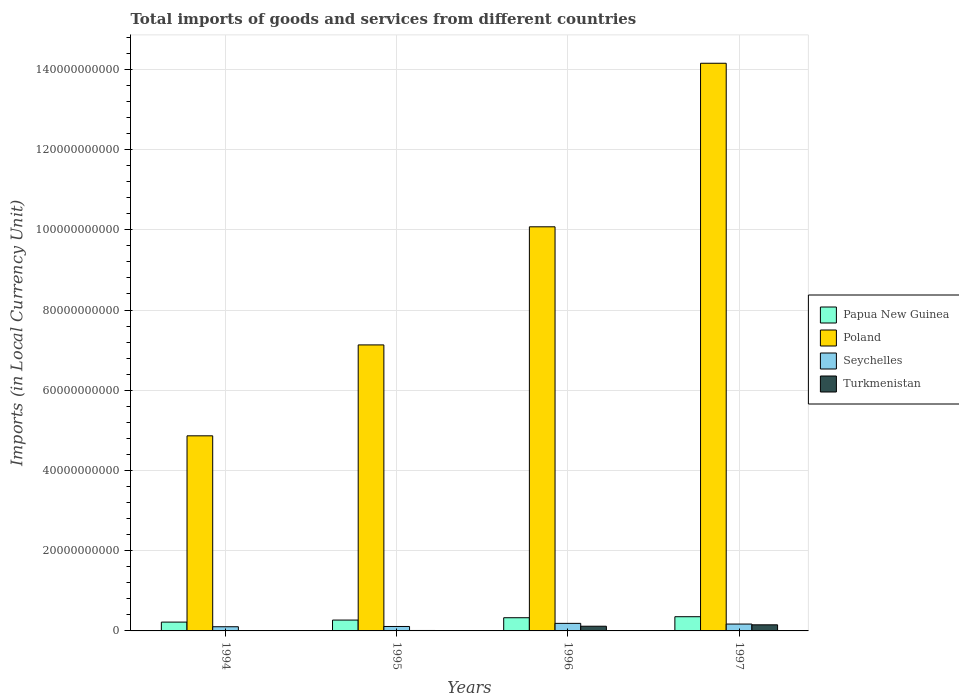How many different coloured bars are there?
Ensure brevity in your answer.  4. How many bars are there on the 2nd tick from the left?
Provide a succinct answer. 4. How many bars are there on the 3rd tick from the right?
Provide a short and direct response. 4. What is the Amount of goods and services imports in Poland in 1997?
Keep it short and to the point. 1.42e+11. Across all years, what is the maximum Amount of goods and services imports in Papua New Guinea?
Your response must be concise. 3.54e+09. Across all years, what is the minimum Amount of goods and services imports in Poland?
Your answer should be very brief. 4.86e+1. In which year was the Amount of goods and services imports in Poland minimum?
Your answer should be compact. 1994. What is the total Amount of goods and services imports in Papua New Guinea in the graph?
Your answer should be compact. 1.17e+1. What is the difference between the Amount of goods and services imports in Papua New Guinea in 1996 and that in 1997?
Provide a short and direct response. -2.55e+08. What is the difference between the Amount of goods and services imports in Seychelles in 1997 and the Amount of goods and services imports in Turkmenistan in 1994?
Make the answer very short. 1.70e+09. What is the average Amount of goods and services imports in Turkmenistan per year?
Provide a short and direct response. 7.04e+08. In the year 1994, what is the difference between the Amount of goods and services imports in Poland and Amount of goods and services imports in Turkmenistan?
Your response must be concise. 4.86e+1. In how many years, is the Amount of goods and services imports in Turkmenistan greater than 8000000000 LCU?
Your answer should be compact. 0. What is the ratio of the Amount of goods and services imports in Seychelles in 1995 to that in 1996?
Provide a succinct answer. 0.59. Is the difference between the Amount of goods and services imports in Poland in 1995 and 1997 greater than the difference between the Amount of goods and services imports in Turkmenistan in 1995 and 1997?
Your response must be concise. No. What is the difference between the highest and the second highest Amount of goods and services imports in Poland?
Make the answer very short. 4.08e+1. What is the difference between the highest and the lowest Amount of goods and services imports in Seychelles?
Your answer should be very brief. 8.40e+08. Is the sum of the Amount of goods and services imports in Poland in 1994 and 1996 greater than the maximum Amount of goods and services imports in Papua New Guinea across all years?
Keep it short and to the point. Yes. Is it the case that in every year, the sum of the Amount of goods and services imports in Seychelles and Amount of goods and services imports in Papua New Guinea is greater than the sum of Amount of goods and services imports in Turkmenistan and Amount of goods and services imports in Poland?
Provide a short and direct response. Yes. What does the 3rd bar from the left in 1995 represents?
Your response must be concise. Seychelles. What does the 3rd bar from the right in 1995 represents?
Offer a terse response. Poland. How many bars are there?
Ensure brevity in your answer.  16. Are all the bars in the graph horizontal?
Provide a succinct answer. No. How many years are there in the graph?
Your response must be concise. 4. Does the graph contain any zero values?
Your answer should be very brief. No. Does the graph contain grids?
Make the answer very short. Yes. How many legend labels are there?
Offer a terse response. 4. How are the legend labels stacked?
Offer a terse response. Vertical. What is the title of the graph?
Offer a very short reply. Total imports of goods and services from different countries. Does "Costa Rica" appear as one of the legend labels in the graph?
Offer a very short reply. No. What is the label or title of the Y-axis?
Offer a very short reply. Imports (in Local Currency Unit). What is the Imports (in Local Currency Unit) in Papua New Guinea in 1994?
Offer a terse response. 2.20e+09. What is the Imports (in Local Currency Unit) in Poland in 1994?
Your response must be concise. 4.86e+1. What is the Imports (in Local Currency Unit) of Seychelles in 1994?
Keep it short and to the point. 1.04e+09. What is the Imports (in Local Currency Unit) in Turkmenistan in 1994?
Your answer should be very brief. 1.49e+07. What is the Imports (in Local Currency Unit) of Papua New Guinea in 1995?
Offer a very short reply. 2.71e+09. What is the Imports (in Local Currency Unit) in Poland in 1995?
Ensure brevity in your answer.  7.13e+1. What is the Imports (in Local Currency Unit) of Seychelles in 1995?
Offer a very short reply. 1.11e+09. What is the Imports (in Local Currency Unit) of Turkmenistan in 1995?
Make the answer very short. 1.10e+08. What is the Imports (in Local Currency Unit) in Papua New Guinea in 1996?
Provide a succinct answer. 3.29e+09. What is the Imports (in Local Currency Unit) of Poland in 1996?
Your response must be concise. 1.01e+11. What is the Imports (in Local Currency Unit) of Seychelles in 1996?
Make the answer very short. 1.88e+09. What is the Imports (in Local Currency Unit) in Turkmenistan in 1996?
Your response must be concise. 1.17e+09. What is the Imports (in Local Currency Unit) in Papua New Guinea in 1997?
Your answer should be compact. 3.54e+09. What is the Imports (in Local Currency Unit) of Poland in 1997?
Your response must be concise. 1.42e+11. What is the Imports (in Local Currency Unit) of Seychelles in 1997?
Provide a short and direct response. 1.71e+09. What is the Imports (in Local Currency Unit) of Turkmenistan in 1997?
Give a very brief answer. 1.52e+09. Across all years, what is the maximum Imports (in Local Currency Unit) of Papua New Guinea?
Make the answer very short. 3.54e+09. Across all years, what is the maximum Imports (in Local Currency Unit) in Poland?
Your answer should be very brief. 1.42e+11. Across all years, what is the maximum Imports (in Local Currency Unit) in Seychelles?
Make the answer very short. 1.88e+09. Across all years, what is the maximum Imports (in Local Currency Unit) in Turkmenistan?
Your response must be concise. 1.52e+09. Across all years, what is the minimum Imports (in Local Currency Unit) of Papua New Guinea?
Your response must be concise. 2.20e+09. Across all years, what is the minimum Imports (in Local Currency Unit) in Poland?
Your answer should be very brief. 4.86e+1. Across all years, what is the minimum Imports (in Local Currency Unit) of Seychelles?
Keep it short and to the point. 1.04e+09. Across all years, what is the minimum Imports (in Local Currency Unit) in Turkmenistan?
Make the answer very short. 1.49e+07. What is the total Imports (in Local Currency Unit) in Papua New Guinea in the graph?
Your answer should be very brief. 1.17e+1. What is the total Imports (in Local Currency Unit) in Poland in the graph?
Your answer should be very brief. 3.62e+11. What is the total Imports (in Local Currency Unit) of Seychelles in the graph?
Ensure brevity in your answer.  5.74e+09. What is the total Imports (in Local Currency Unit) of Turkmenistan in the graph?
Offer a terse response. 2.82e+09. What is the difference between the Imports (in Local Currency Unit) of Papua New Guinea in 1994 and that in 1995?
Give a very brief answer. -5.08e+08. What is the difference between the Imports (in Local Currency Unit) in Poland in 1994 and that in 1995?
Make the answer very short. -2.27e+1. What is the difference between the Imports (in Local Currency Unit) of Seychelles in 1994 and that in 1995?
Your answer should be very brief. -6.68e+07. What is the difference between the Imports (in Local Currency Unit) of Turkmenistan in 1994 and that in 1995?
Keep it short and to the point. -9.49e+07. What is the difference between the Imports (in Local Currency Unit) in Papua New Guinea in 1994 and that in 1996?
Make the answer very short. -1.09e+09. What is the difference between the Imports (in Local Currency Unit) in Poland in 1994 and that in 1996?
Provide a succinct answer. -5.21e+1. What is the difference between the Imports (in Local Currency Unit) of Seychelles in 1994 and that in 1996?
Ensure brevity in your answer.  -8.40e+08. What is the difference between the Imports (in Local Currency Unit) of Turkmenistan in 1994 and that in 1996?
Ensure brevity in your answer.  -1.15e+09. What is the difference between the Imports (in Local Currency Unit) of Papua New Guinea in 1994 and that in 1997?
Give a very brief answer. -1.34e+09. What is the difference between the Imports (in Local Currency Unit) of Poland in 1994 and that in 1997?
Your answer should be very brief. -9.29e+1. What is the difference between the Imports (in Local Currency Unit) in Seychelles in 1994 and that in 1997?
Make the answer very short. -6.69e+08. What is the difference between the Imports (in Local Currency Unit) in Turkmenistan in 1994 and that in 1997?
Keep it short and to the point. -1.51e+09. What is the difference between the Imports (in Local Currency Unit) in Papua New Guinea in 1995 and that in 1996?
Make the answer very short. -5.81e+08. What is the difference between the Imports (in Local Currency Unit) in Poland in 1995 and that in 1996?
Your answer should be very brief. -2.94e+1. What is the difference between the Imports (in Local Currency Unit) of Seychelles in 1995 and that in 1996?
Your answer should be very brief. -7.73e+08. What is the difference between the Imports (in Local Currency Unit) of Turkmenistan in 1995 and that in 1996?
Provide a short and direct response. -1.06e+09. What is the difference between the Imports (in Local Currency Unit) in Papua New Guinea in 1995 and that in 1997?
Offer a very short reply. -8.36e+08. What is the difference between the Imports (in Local Currency Unit) of Poland in 1995 and that in 1997?
Your answer should be very brief. -7.02e+1. What is the difference between the Imports (in Local Currency Unit) in Seychelles in 1995 and that in 1997?
Give a very brief answer. -6.02e+08. What is the difference between the Imports (in Local Currency Unit) in Turkmenistan in 1995 and that in 1997?
Provide a succinct answer. -1.41e+09. What is the difference between the Imports (in Local Currency Unit) in Papua New Guinea in 1996 and that in 1997?
Give a very brief answer. -2.55e+08. What is the difference between the Imports (in Local Currency Unit) in Poland in 1996 and that in 1997?
Provide a succinct answer. -4.08e+1. What is the difference between the Imports (in Local Currency Unit) in Seychelles in 1996 and that in 1997?
Offer a very short reply. 1.71e+08. What is the difference between the Imports (in Local Currency Unit) in Turkmenistan in 1996 and that in 1997?
Make the answer very short. -3.54e+08. What is the difference between the Imports (in Local Currency Unit) of Papua New Guinea in 1994 and the Imports (in Local Currency Unit) of Poland in 1995?
Keep it short and to the point. -6.91e+1. What is the difference between the Imports (in Local Currency Unit) in Papua New Guinea in 1994 and the Imports (in Local Currency Unit) in Seychelles in 1995?
Provide a short and direct response. 1.09e+09. What is the difference between the Imports (in Local Currency Unit) in Papua New Guinea in 1994 and the Imports (in Local Currency Unit) in Turkmenistan in 1995?
Provide a short and direct response. 2.09e+09. What is the difference between the Imports (in Local Currency Unit) in Poland in 1994 and the Imports (in Local Currency Unit) in Seychelles in 1995?
Your answer should be compact. 4.75e+1. What is the difference between the Imports (in Local Currency Unit) of Poland in 1994 and the Imports (in Local Currency Unit) of Turkmenistan in 1995?
Give a very brief answer. 4.85e+1. What is the difference between the Imports (in Local Currency Unit) in Seychelles in 1994 and the Imports (in Local Currency Unit) in Turkmenistan in 1995?
Offer a terse response. 9.33e+08. What is the difference between the Imports (in Local Currency Unit) of Papua New Guinea in 1994 and the Imports (in Local Currency Unit) of Poland in 1996?
Make the answer very short. -9.86e+1. What is the difference between the Imports (in Local Currency Unit) of Papua New Guinea in 1994 and the Imports (in Local Currency Unit) of Seychelles in 1996?
Provide a succinct answer. 3.17e+08. What is the difference between the Imports (in Local Currency Unit) in Papua New Guinea in 1994 and the Imports (in Local Currency Unit) in Turkmenistan in 1996?
Make the answer very short. 1.03e+09. What is the difference between the Imports (in Local Currency Unit) of Poland in 1994 and the Imports (in Local Currency Unit) of Seychelles in 1996?
Keep it short and to the point. 4.68e+1. What is the difference between the Imports (in Local Currency Unit) in Poland in 1994 and the Imports (in Local Currency Unit) in Turkmenistan in 1996?
Offer a very short reply. 4.75e+1. What is the difference between the Imports (in Local Currency Unit) of Seychelles in 1994 and the Imports (in Local Currency Unit) of Turkmenistan in 1996?
Offer a very short reply. -1.27e+08. What is the difference between the Imports (in Local Currency Unit) in Papua New Guinea in 1994 and the Imports (in Local Currency Unit) in Poland in 1997?
Your answer should be very brief. -1.39e+11. What is the difference between the Imports (in Local Currency Unit) in Papua New Guinea in 1994 and the Imports (in Local Currency Unit) in Seychelles in 1997?
Make the answer very short. 4.88e+08. What is the difference between the Imports (in Local Currency Unit) in Papua New Guinea in 1994 and the Imports (in Local Currency Unit) in Turkmenistan in 1997?
Your response must be concise. 6.76e+08. What is the difference between the Imports (in Local Currency Unit) of Poland in 1994 and the Imports (in Local Currency Unit) of Seychelles in 1997?
Provide a short and direct response. 4.69e+1. What is the difference between the Imports (in Local Currency Unit) of Poland in 1994 and the Imports (in Local Currency Unit) of Turkmenistan in 1997?
Provide a short and direct response. 4.71e+1. What is the difference between the Imports (in Local Currency Unit) of Seychelles in 1994 and the Imports (in Local Currency Unit) of Turkmenistan in 1997?
Give a very brief answer. -4.81e+08. What is the difference between the Imports (in Local Currency Unit) of Papua New Guinea in 1995 and the Imports (in Local Currency Unit) of Poland in 1996?
Keep it short and to the point. -9.80e+1. What is the difference between the Imports (in Local Currency Unit) in Papua New Guinea in 1995 and the Imports (in Local Currency Unit) in Seychelles in 1996?
Provide a short and direct response. 8.25e+08. What is the difference between the Imports (in Local Currency Unit) in Papua New Guinea in 1995 and the Imports (in Local Currency Unit) in Turkmenistan in 1996?
Provide a succinct answer. 1.54e+09. What is the difference between the Imports (in Local Currency Unit) of Poland in 1995 and the Imports (in Local Currency Unit) of Seychelles in 1996?
Your answer should be very brief. 6.94e+1. What is the difference between the Imports (in Local Currency Unit) in Poland in 1995 and the Imports (in Local Currency Unit) in Turkmenistan in 1996?
Make the answer very short. 7.01e+1. What is the difference between the Imports (in Local Currency Unit) of Seychelles in 1995 and the Imports (in Local Currency Unit) of Turkmenistan in 1996?
Your answer should be compact. -5.99e+07. What is the difference between the Imports (in Local Currency Unit) in Papua New Guinea in 1995 and the Imports (in Local Currency Unit) in Poland in 1997?
Keep it short and to the point. -1.39e+11. What is the difference between the Imports (in Local Currency Unit) of Papua New Guinea in 1995 and the Imports (in Local Currency Unit) of Seychelles in 1997?
Provide a succinct answer. 9.96e+08. What is the difference between the Imports (in Local Currency Unit) of Papua New Guinea in 1995 and the Imports (in Local Currency Unit) of Turkmenistan in 1997?
Keep it short and to the point. 1.18e+09. What is the difference between the Imports (in Local Currency Unit) in Poland in 1995 and the Imports (in Local Currency Unit) in Seychelles in 1997?
Offer a terse response. 6.96e+1. What is the difference between the Imports (in Local Currency Unit) of Poland in 1995 and the Imports (in Local Currency Unit) of Turkmenistan in 1997?
Keep it short and to the point. 6.98e+1. What is the difference between the Imports (in Local Currency Unit) in Seychelles in 1995 and the Imports (in Local Currency Unit) in Turkmenistan in 1997?
Offer a terse response. -4.14e+08. What is the difference between the Imports (in Local Currency Unit) in Papua New Guinea in 1996 and the Imports (in Local Currency Unit) in Poland in 1997?
Your answer should be very brief. -1.38e+11. What is the difference between the Imports (in Local Currency Unit) in Papua New Guinea in 1996 and the Imports (in Local Currency Unit) in Seychelles in 1997?
Your answer should be compact. 1.58e+09. What is the difference between the Imports (in Local Currency Unit) of Papua New Guinea in 1996 and the Imports (in Local Currency Unit) of Turkmenistan in 1997?
Your response must be concise. 1.77e+09. What is the difference between the Imports (in Local Currency Unit) in Poland in 1996 and the Imports (in Local Currency Unit) in Seychelles in 1997?
Your answer should be very brief. 9.90e+1. What is the difference between the Imports (in Local Currency Unit) of Poland in 1996 and the Imports (in Local Currency Unit) of Turkmenistan in 1997?
Provide a succinct answer. 9.92e+1. What is the difference between the Imports (in Local Currency Unit) of Seychelles in 1996 and the Imports (in Local Currency Unit) of Turkmenistan in 1997?
Offer a terse response. 3.59e+08. What is the average Imports (in Local Currency Unit) in Papua New Guinea per year?
Offer a terse response. 2.93e+09. What is the average Imports (in Local Currency Unit) of Poland per year?
Offer a very short reply. 9.06e+1. What is the average Imports (in Local Currency Unit) in Seychelles per year?
Ensure brevity in your answer.  1.44e+09. What is the average Imports (in Local Currency Unit) of Turkmenistan per year?
Make the answer very short. 7.04e+08. In the year 1994, what is the difference between the Imports (in Local Currency Unit) in Papua New Guinea and Imports (in Local Currency Unit) in Poland?
Provide a short and direct response. -4.64e+1. In the year 1994, what is the difference between the Imports (in Local Currency Unit) in Papua New Guinea and Imports (in Local Currency Unit) in Seychelles?
Your answer should be very brief. 1.16e+09. In the year 1994, what is the difference between the Imports (in Local Currency Unit) of Papua New Guinea and Imports (in Local Currency Unit) of Turkmenistan?
Your answer should be very brief. 2.18e+09. In the year 1994, what is the difference between the Imports (in Local Currency Unit) in Poland and Imports (in Local Currency Unit) in Seychelles?
Offer a very short reply. 4.76e+1. In the year 1994, what is the difference between the Imports (in Local Currency Unit) in Poland and Imports (in Local Currency Unit) in Turkmenistan?
Your answer should be compact. 4.86e+1. In the year 1994, what is the difference between the Imports (in Local Currency Unit) of Seychelles and Imports (in Local Currency Unit) of Turkmenistan?
Offer a terse response. 1.03e+09. In the year 1995, what is the difference between the Imports (in Local Currency Unit) of Papua New Guinea and Imports (in Local Currency Unit) of Poland?
Your response must be concise. -6.86e+1. In the year 1995, what is the difference between the Imports (in Local Currency Unit) of Papua New Guinea and Imports (in Local Currency Unit) of Seychelles?
Make the answer very short. 1.60e+09. In the year 1995, what is the difference between the Imports (in Local Currency Unit) in Papua New Guinea and Imports (in Local Currency Unit) in Turkmenistan?
Provide a succinct answer. 2.60e+09. In the year 1995, what is the difference between the Imports (in Local Currency Unit) of Poland and Imports (in Local Currency Unit) of Seychelles?
Your answer should be compact. 7.02e+1. In the year 1995, what is the difference between the Imports (in Local Currency Unit) of Poland and Imports (in Local Currency Unit) of Turkmenistan?
Your response must be concise. 7.12e+1. In the year 1995, what is the difference between the Imports (in Local Currency Unit) of Seychelles and Imports (in Local Currency Unit) of Turkmenistan?
Your response must be concise. 9.99e+08. In the year 1996, what is the difference between the Imports (in Local Currency Unit) of Papua New Guinea and Imports (in Local Currency Unit) of Poland?
Your response must be concise. -9.75e+1. In the year 1996, what is the difference between the Imports (in Local Currency Unit) of Papua New Guinea and Imports (in Local Currency Unit) of Seychelles?
Your answer should be compact. 1.41e+09. In the year 1996, what is the difference between the Imports (in Local Currency Unit) of Papua New Guinea and Imports (in Local Currency Unit) of Turkmenistan?
Your response must be concise. 2.12e+09. In the year 1996, what is the difference between the Imports (in Local Currency Unit) in Poland and Imports (in Local Currency Unit) in Seychelles?
Your answer should be very brief. 9.89e+1. In the year 1996, what is the difference between the Imports (in Local Currency Unit) of Poland and Imports (in Local Currency Unit) of Turkmenistan?
Keep it short and to the point. 9.96e+1. In the year 1996, what is the difference between the Imports (in Local Currency Unit) of Seychelles and Imports (in Local Currency Unit) of Turkmenistan?
Your answer should be very brief. 7.13e+08. In the year 1997, what is the difference between the Imports (in Local Currency Unit) in Papua New Guinea and Imports (in Local Currency Unit) in Poland?
Offer a terse response. -1.38e+11. In the year 1997, what is the difference between the Imports (in Local Currency Unit) in Papua New Guinea and Imports (in Local Currency Unit) in Seychelles?
Give a very brief answer. 1.83e+09. In the year 1997, what is the difference between the Imports (in Local Currency Unit) in Papua New Guinea and Imports (in Local Currency Unit) in Turkmenistan?
Your answer should be very brief. 2.02e+09. In the year 1997, what is the difference between the Imports (in Local Currency Unit) in Poland and Imports (in Local Currency Unit) in Seychelles?
Make the answer very short. 1.40e+11. In the year 1997, what is the difference between the Imports (in Local Currency Unit) of Poland and Imports (in Local Currency Unit) of Turkmenistan?
Make the answer very short. 1.40e+11. In the year 1997, what is the difference between the Imports (in Local Currency Unit) of Seychelles and Imports (in Local Currency Unit) of Turkmenistan?
Your response must be concise. 1.88e+08. What is the ratio of the Imports (in Local Currency Unit) of Papua New Guinea in 1994 to that in 1995?
Give a very brief answer. 0.81. What is the ratio of the Imports (in Local Currency Unit) of Poland in 1994 to that in 1995?
Your answer should be very brief. 0.68. What is the ratio of the Imports (in Local Currency Unit) in Seychelles in 1994 to that in 1995?
Offer a terse response. 0.94. What is the ratio of the Imports (in Local Currency Unit) in Turkmenistan in 1994 to that in 1995?
Offer a very short reply. 0.14. What is the ratio of the Imports (in Local Currency Unit) of Papua New Guinea in 1994 to that in 1996?
Your response must be concise. 0.67. What is the ratio of the Imports (in Local Currency Unit) in Poland in 1994 to that in 1996?
Provide a short and direct response. 0.48. What is the ratio of the Imports (in Local Currency Unit) in Seychelles in 1994 to that in 1996?
Ensure brevity in your answer.  0.55. What is the ratio of the Imports (in Local Currency Unit) in Turkmenistan in 1994 to that in 1996?
Make the answer very short. 0.01. What is the ratio of the Imports (in Local Currency Unit) in Papua New Guinea in 1994 to that in 1997?
Ensure brevity in your answer.  0.62. What is the ratio of the Imports (in Local Currency Unit) of Poland in 1994 to that in 1997?
Your answer should be compact. 0.34. What is the ratio of the Imports (in Local Currency Unit) of Seychelles in 1994 to that in 1997?
Provide a short and direct response. 0.61. What is the ratio of the Imports (in Local Currency Unit) in Turkmenistan in 1994 to that in 1997?
Keep it short and to the point. 0.01. What is the ratio of the Imports (in Local Currency Unit) of Papua New Guinea in 1995 to that in 1996?
Make the answer very short. 0.82. What is the ratio of the Imports (in Local Currency Unit) in Poland in 1995 to that in 1996?
Provide a short and direct response. 0.71. What is the ratio of the Imports (in Local Currency Unit) of Seychelles in 1995 to that in 1996?
Your answer should be very brief. 0.59. What is the ratio of the Imports (in Local Currency Unit) of Turkmenistan in 1995 to that in 1996?
Your response must be concise. 0.09. What is the ratio of the Imports (in Local Currency Unit) in Papua New Guinea in 1995 to that in 1997?
Offer a very short reply. 0.76. What is the ratio of the Imports (in Local Currency Unit) of Poland in 1995 to that in 1997?
Make the answer very short. 0.5. What is the ratio of the Imports (in Local Currency Unit) of Seychelles in 1995 to that in 1997?
Your answer should be very brief. 0.65. What is the ratio of the Imports (in Local Currency Unit) of Turkmenistan in 1995 to that in 1997?
Your answer should be compact. 0.07. What is the ratio of the Imports (in Local Currency Unit) of Papua New Guinea in 1996 to that in 1997?
Provide a succinct answer. 0.93. What is the ratio of the Imports (in Local Currency Unit) of Poland in 1996 to that in 1997?
Keep it short and to the point. 0.71. What is the ratio of the Imports (in Local Currency Unit) of Seychelles in 1996 to that in 1997?
Your response must be concise. 1.1. What is the ratio of the Imports (in Local Currency Unit) in Turkmenistan in 1996 to that in 1997?
Keep it short and to the point. 0.77. What is the difference between the highest and the second highest Imports (in Local Currency Unit) in Papua New Guinea?
Your answer should be compact. 2.55e+08. What is the difference between the highest and the second highest Imports (in Local Currency Unit) in Poland?
Keep it short and to the point. 4.08e+1. What is the difference between the highest and the second highest Imports (in Local Currency Unit) in Seychelles?
Ensure brevity in your answer.  1.71e+08. What is the difference between the highest and the second highest Imports (in Local Currency Unit) of Turkmenistan?
Offer a terse response. 3.54e+08. What is the difference between the highest and the lowest Imports (in Local Currency Unit) of Papua New Guinea?
Offer a very short reply. 1.34e+09. What is the difference between the highest and the lowest Imports (in Local Currency Unit) in Poland?
Ensure brevity in your answer.  9.29e+1. What is the difference between the highest and the lowest Imports (in Local Currency Unit) of Seychelles?
Give a very brief answer. 8.40e+08. What is the difference between the highest and the lowest Imports (in Local Currency Unit) of Turkmenistan?
Keep it short and to the point. 1.51e+09. 